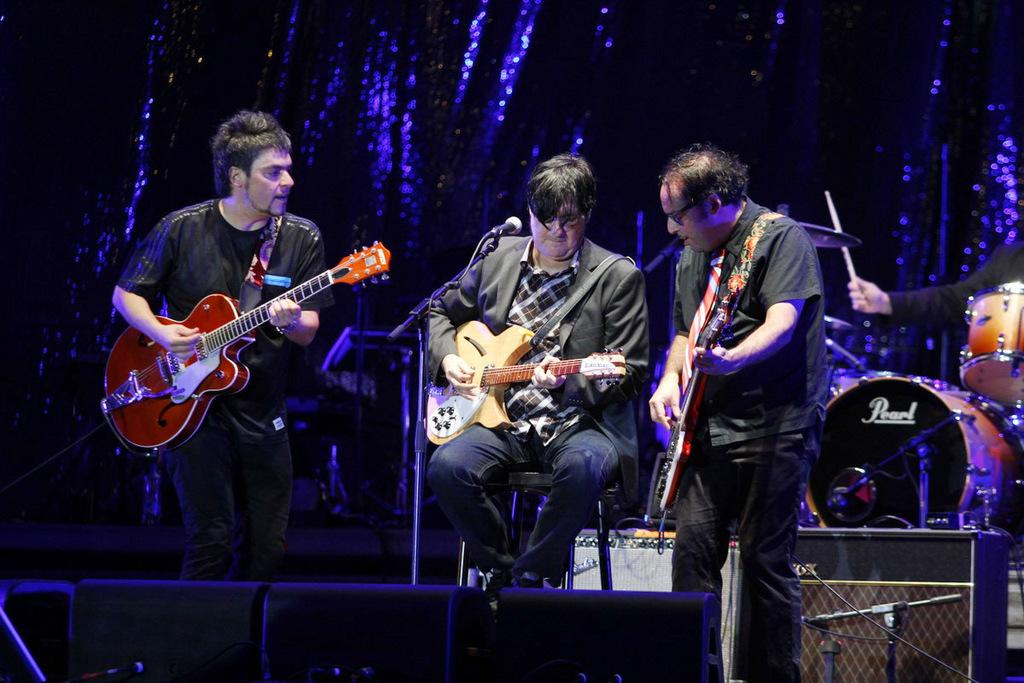How many people are in the image? There are three persons in the image. What is one person doing in the image? One person is sitting and playing a musical instrument. What object is present in the image that is typically used for amplifying sound? There is a microphone (mic) in the image. What is the microphone attached to in the image? There is a stand associated with the microphone in the image. What type of yam is being used as a prop in the image? There is no yam present in the image; it features three persons and a microphone with a stand. 